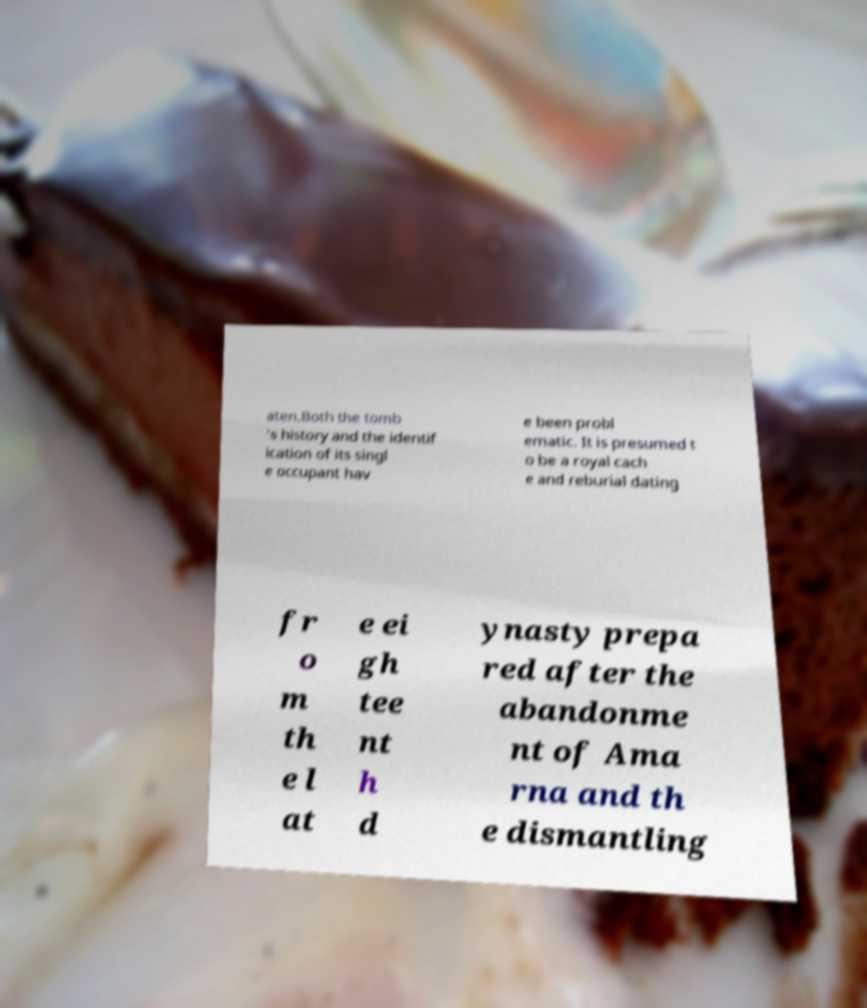Could you extract and type out the text from this image? aten.Both the tomb 's history and the identif ication of its singl e occupant hav e been probl ematic. It is presumed t o be a royal cach e and reburial dating fr o m th e l at e ei gh tee nt h d ynasty prepa red after the abandonme nt of Ama rna and th e dismantling 